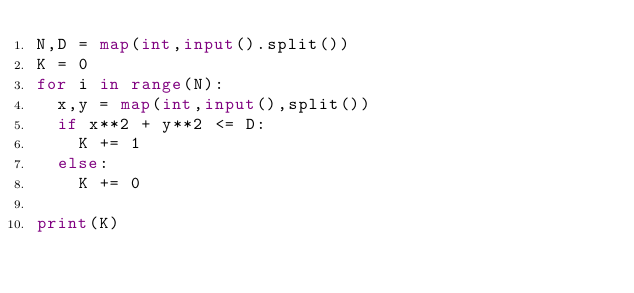Convert code to text. <code><loc_0><loc_0><loc_500><loc_500><_Python_>N,D = map(int,input().split())
K = 0
for i in range(N):
  x,y = map(int,input(),split())
  if x**2 + y**2 <= D:
    K += 1
  else:
    K += 0

print(K)</code> 